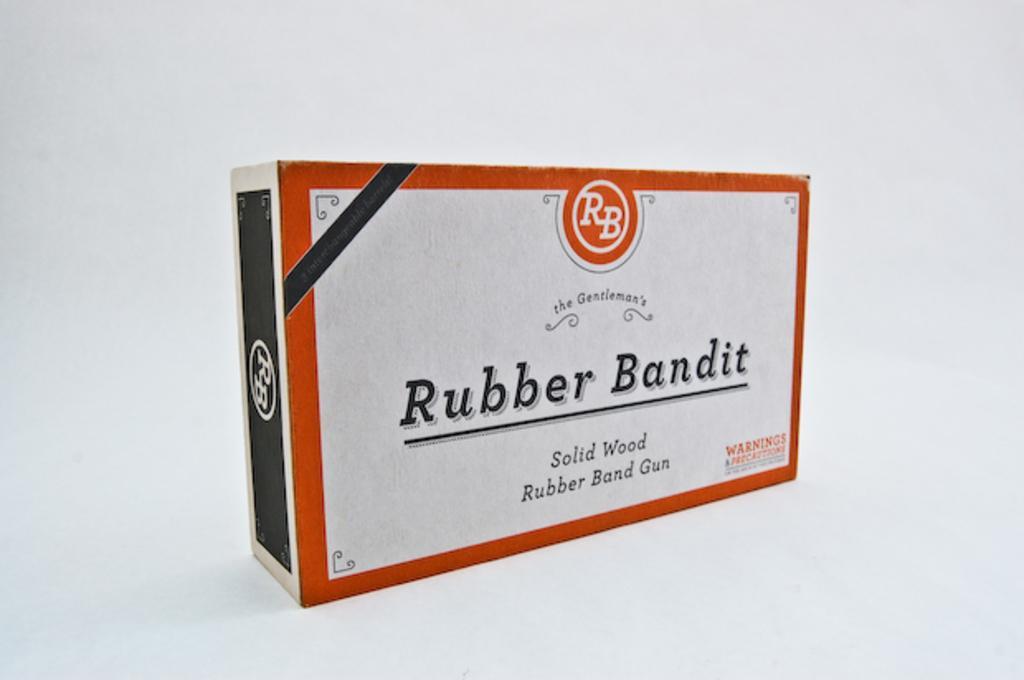Can you describe this image briefly? This picture contains a box which is in white, red and black color. On the box, it is written as "Rubber Bandit". This might be a rubber or an eraser. In the background, it is white in color. 